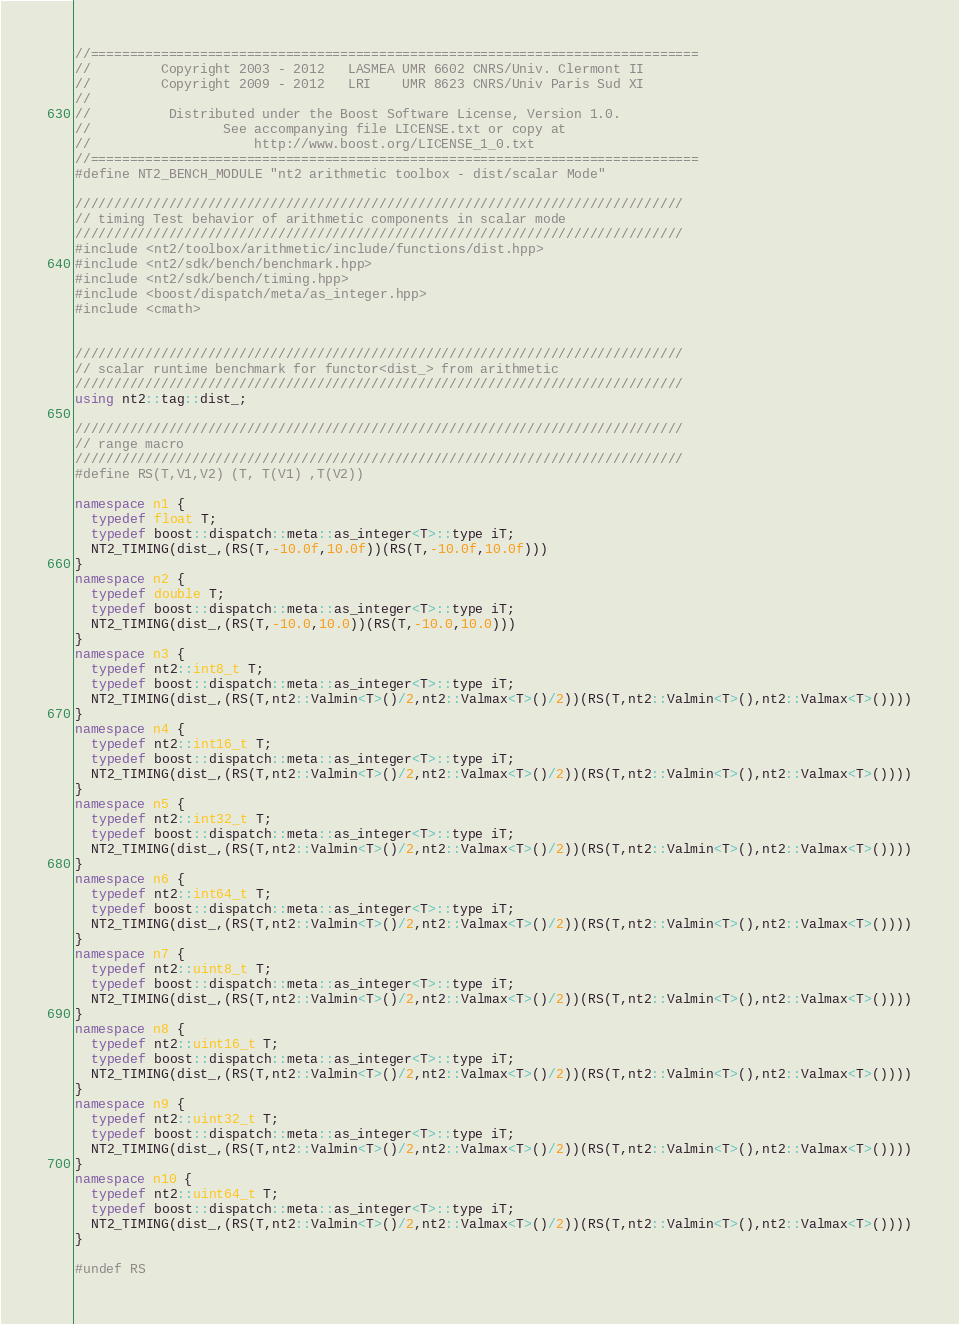<code> <loc_0><loc_0><loc_500><loc_500><_C++_>//==============================================================================
//         Copyright 2003 - 2012   LASMEA UMR 6602 CNRS/Univ. Clermont II
//         Copyright 2009 - 2012   LRI    UMR 8623 CNRS/Univ Paris Sud XI
//
//          Distributed under the Boost Software License, Version 1.0.
//                 See accompanying file LICENSE.txt or copy at
//                     http://www.boost.org/LICENSE_1_0.txt
//==============================================================================
#define NT2_BENCH_MODULE "nt2 arithmetic toolbox - dist/scalar Mode"

//////////////////////////////////////////////////////////////////////////////
// timing Test behavior of arithmetic components in scalar mode
//////////////////////////////////////////////////////////////////////////////
#include <nt2/toolbox/arithmetic/include/functions/dist.hpp>
#include <nt2/sdk/bench/benchmark.hpp>
#include <nt2/sdk/bench/timing.hpp>
#include <boost/dispatch/meta/as_integer.hpp>
#include <cmath>


//////////////////////////////////////////////////////////////////////////////
// scalar runtime benchmark for functor<dist_> from arithmetic
//////////////////////////////////////////////////////////////////////////////
using nt2::tag::dist_;

//////////////////////////////////////////////////////////////////////////////
// range macro
//////////////////////////////////////////////////////////////////////////////
#define RS(T,V1,V2) (T, T(V1) ,T(V2))

namespace n1 {
  typedef float T;
  typedef boost::dispatch::meta::as_integer<T>::type iT;
  NT2_TIMING(dist_,(RS(T,-10.0f,10.0f))(RS(T,-10.0f,10.0f)))
}
namespace n2 {
  typedef double T;
  typedef boost::dispatch::meta::as_integer<T>::type iT;
  NT2_TIMING(dist_,(RS(T,-10.0,10.0))(RS(T,-10.0,10.0)))
}
namespace n3 {
  typedef nt2::int8_t T;
  typedef boost::dispatch::meta::as_integer<T>::type iT;
  NT2_TIMING(dist_,(RS(T,nt2::Valmin<T>()/2,nt2::Valmax<T>()/2))(RS(T,nt2::Valmin<T>(),nt2::Valmax<T>())))
}
namespace n4 {
  typedef nt2::int16_t T;
  typedef boost::dispatch::meta::as_integer<T>::type iT;
  NT2_TIMING(dist_,(RS(T,nt2::Valmin<T>()/2,nt2::Valmax<T>()/2))(RS(T,nt2::Valmin<T>(),nt2::Valmax<T>())))
}
namespace n5 {
  typedef nt2::int32_t T;
  typedef boost::dispatch::meta::as_integer<T>::type iT;
  NT2_TIMING(dist_,(RS(T,nt2::Valmin<T>()/2,nt2::Valmax<T>()/2))(RS(T,nt2::Valmin<T>(),nt2::Valmax<T>())))
}
namespace n6 {
  typedef nt2::int64_t T;
  typedef boost::dispatch::meta::as_integer<T>::type iT;
  NT2_TIMING(dist_,(RS(T,nt2::Valmin<T>()/2,nt2::Valmax<T>()/2))(RS(T,nt2::Valmin<T>(),nt2::Valmax<T>())))
}
namespace n7 {
  typedef nt2::uint8_t T;
  typedef boost::dispatch::meta::as_integer<T>::type iT;
  NT2_TIMING(dist_,(RS(T,nt2::Valmin<T>()/2,nt2::Valmax<T>()/2))(RS(T,nt2::Valmin<T>(),nt2::Valmax<T>())))
}
namespace n8 {
  typedef nt2::uint16_t T;
  typedef boost::dispatch::meta::as_integer<T>::type iT;
  NT2_TIMING(dist_,(RS(T,nt2::Valmin<T>()/2,nt2::Valmax<T>()/2))(RS(T,nt2::Valmin<T>(),nt2::Valmax<T>())))
}
namespace n9 {
  typedef nt2::uint32_t T;
  typedef boost::dispatch::meta::as_integer<T>::type iT;
  NT2_TIMING(dist_,(RS(T,nt2::Valmin<T>()/2,nt2::Valmax<T>()/2))(RS(T,nt2::Valmin<T>(),nt2::Valmax<T>())))
}
namespace n10 {
  typedef nt2::uint64_t T;
  typedef boost::dispatch::meta::as_integer<T>::type iT;
  NT2_TIMING(dist_,(RS(T,nt2::Valmin<T>()/2,nt2::Valmax<T>()/2))(RS(T,nt2::Valmin<T>(),nt2::Valmax<T>())))
}

#undef RS
</code> 